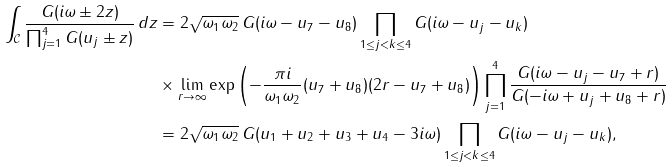Convert formula to latex. <formula><loc_0><loc_0><loc_500><loc_500>\int _ { \mathcal { C } } \frac { G ( i \omega \pm 2 z ) } { \prod _ { j = 1 } ^ { 4 } G ( u _ { j } \pm z ) } \, d z & = 2 \sqrt { \omega _ { 1 } \omega _ { 2 } } \, G ( i \omega - u _ { 7 } - u _ { 8 } ) \prod _ { 1 \leq j < k \leq 4 } G ( i \omega - u _ { j } - u _ { k } ) \\ & \times \lim _ { r \rightarrow \infty } \exp \left ( - \frac { \pi i } { \omega _ { 1 } \omega _ { 2 } } ( u _ { 7 } + u _ { 8 } ) ( 2 r - u _ { 7 } + u _ { 8 } ) \right ) \prod _ { j = 1 } ^ { 4 } \frac { G ( i \omega - u _ { j } - u _ { 7 } + r ) } { G ( - i \omega + u _ { j } + u _ { 8 } + r ) } \\ & = 2 \sqrt { \omega _ { 1 } \omega _ { 2 } } \, G ( u _ { 1 } + u _ { 2 } + u _ { 3 } + u _ { 4 } - 3 i \omega ) \prod _ { 1 \leq j < k \leq 4 } G ( i \omega - u _ { j } - u _ { k } ) ,</formula> 